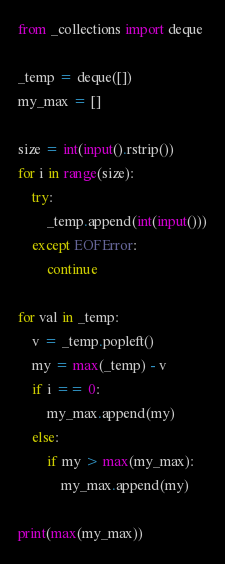<code> <loc_0><loc_0><loc_500><loc_500><_Python_>from _collections import deque

_temp = deque([])
my_max = []

size = int(input().rstrip())
for i in range(size):
    try:
        _temp.append(int(input()))
    except EOFError:
        continue

for val in _temp:
    v = _temp.popleft()
    my = max(_temp) - v
    if i == 0:
        my_max.append(my)
    else:
        if my > max(my_max):
            my_max.append(my)

print(max(my_max))</code> 